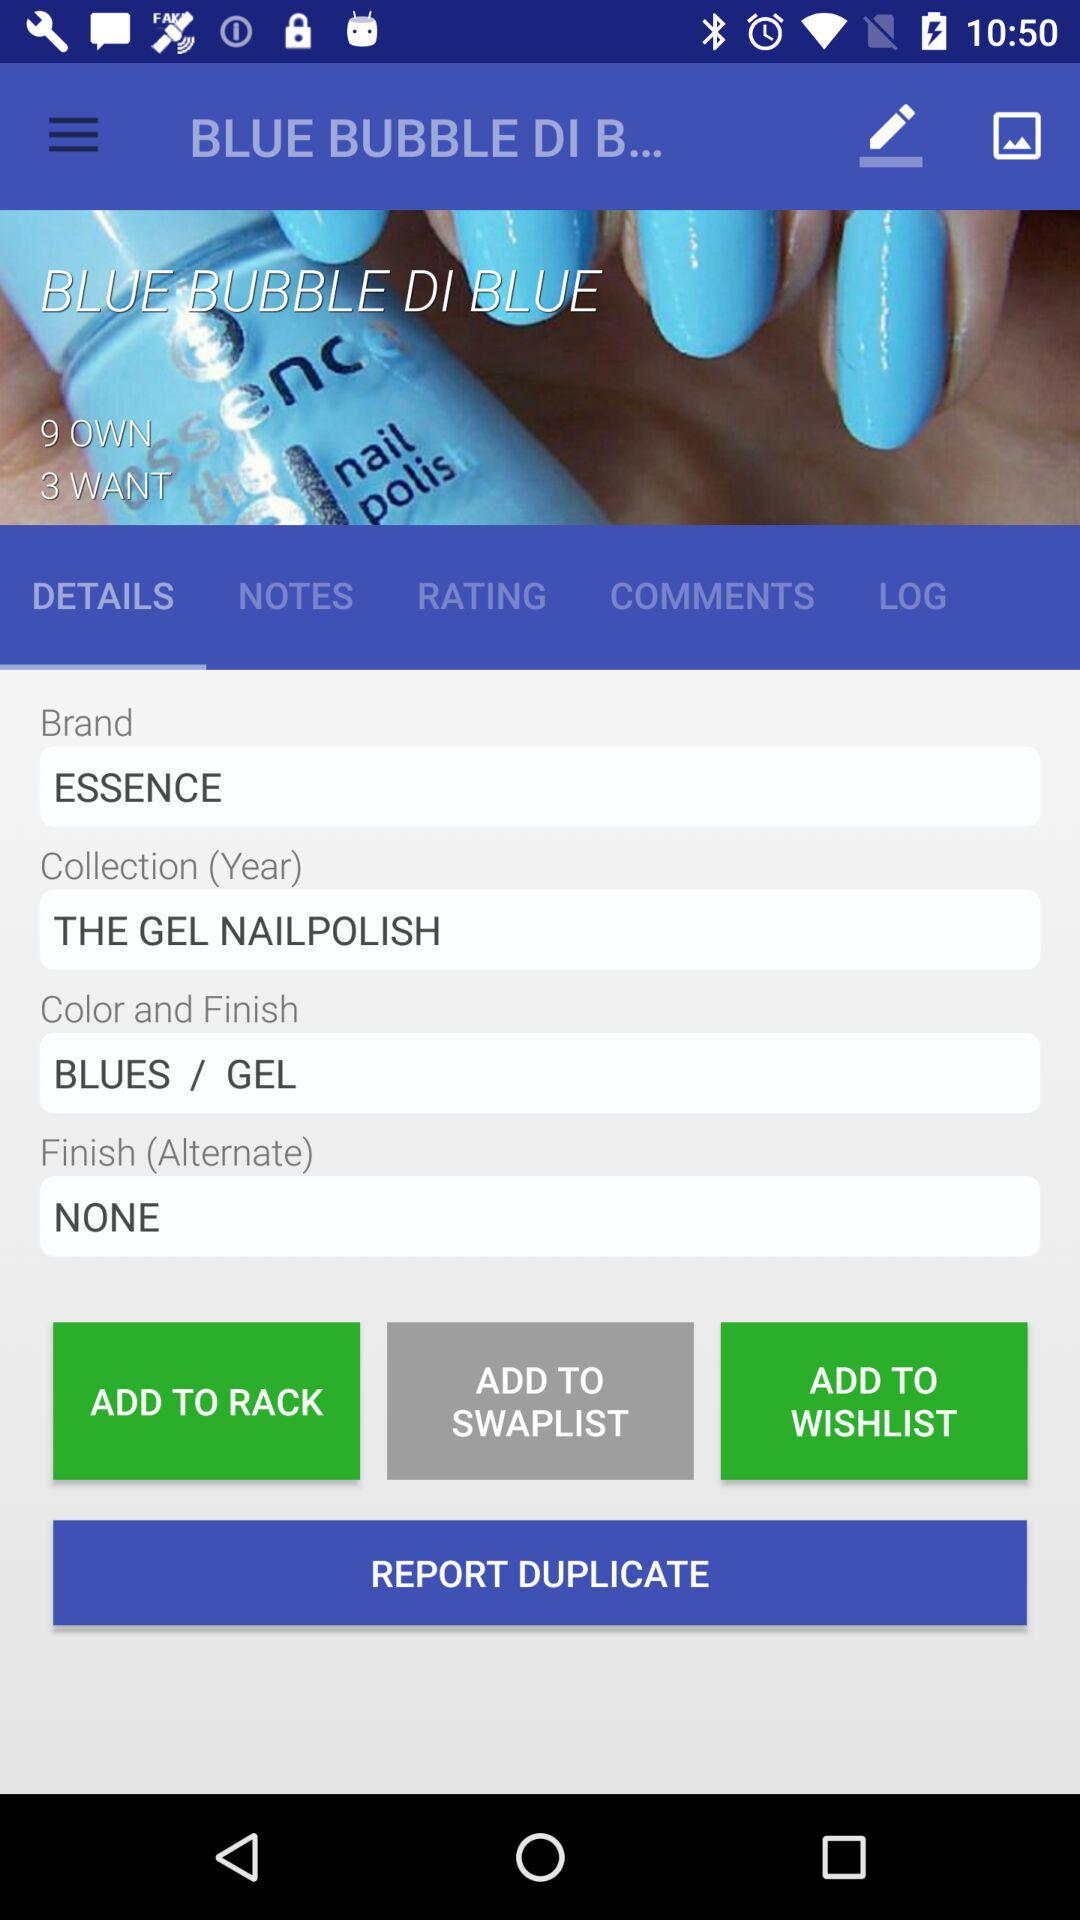What is the number of items want?
When the provided information is insufficient, respond with <no answer>. <no answer> 